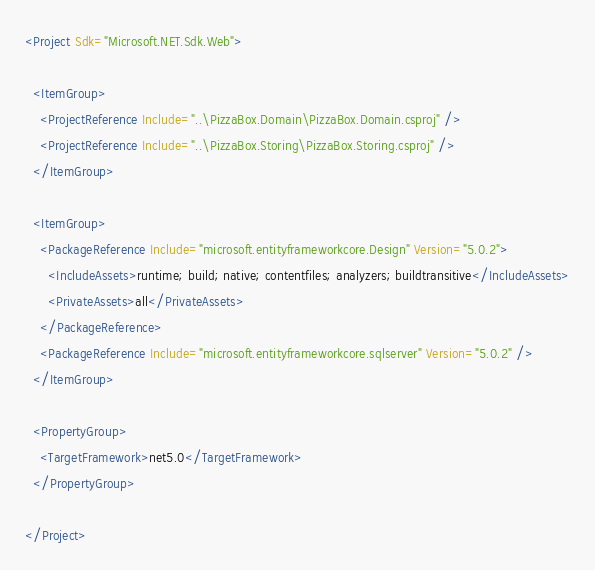<code> <loc_0><loc_0><loc_500><loc_500><_XML_><Project Sdk="Microsoft.NET.Sdk.Web">

  <ItemGroup>
    <ProjectReference Include="..\PizzaBox.Domain\PizzaBox.Domain.csproj" />
    <ProjectReference Include="..\PizzaBox.Storing\PizzaBox.Storing.csproj" />
  </ItemGroup>

  <ItemGroup>
    <PackageReference Include="microsoft.entityframeworkcore.Design" Version="5.0.2">
      <IncludeAssets>runtime; build; native; contentfiles; analyzers; buildtransitive</IncludeAssets>
      <PrivateAssets>all</PrivateAssets>
    </PackageReference>
    <PackageReference Include="microsoft.entityframeworkcore.sqlserver" Version="5.0.2" />
  </ItemGroup>

  <PropertyGroup>
    <TargetFramework>net5.0</TargetFramework>
  </PropertyGroup>

</Project>
</code> 